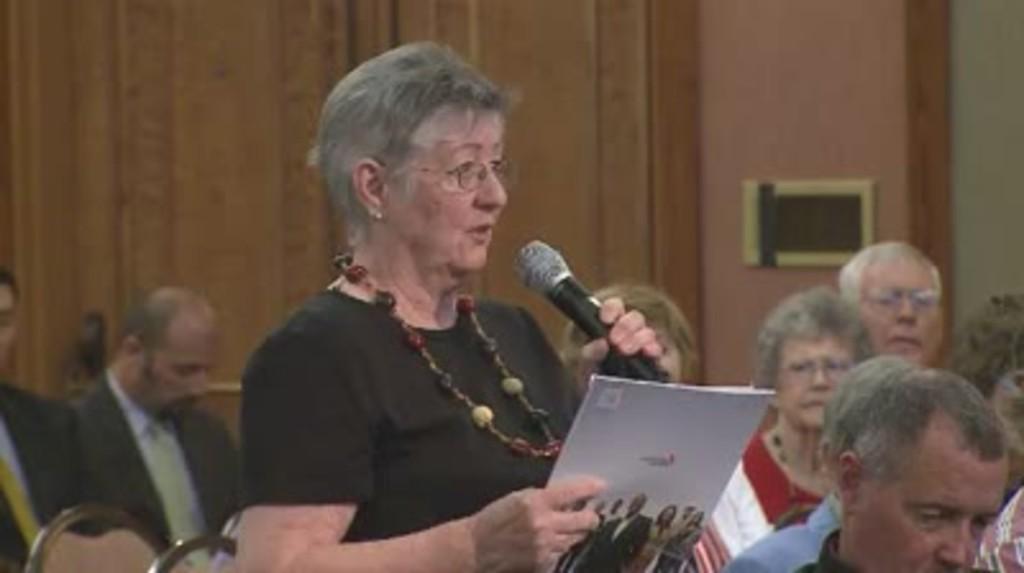In one or two sentences, can you explain what this image depicts? In this picture we can see woman holding mic in her hand and talking and holding book in other hand and beside to her and at back of her we can see some persons sitting and looking at her and in background we can see wall. 